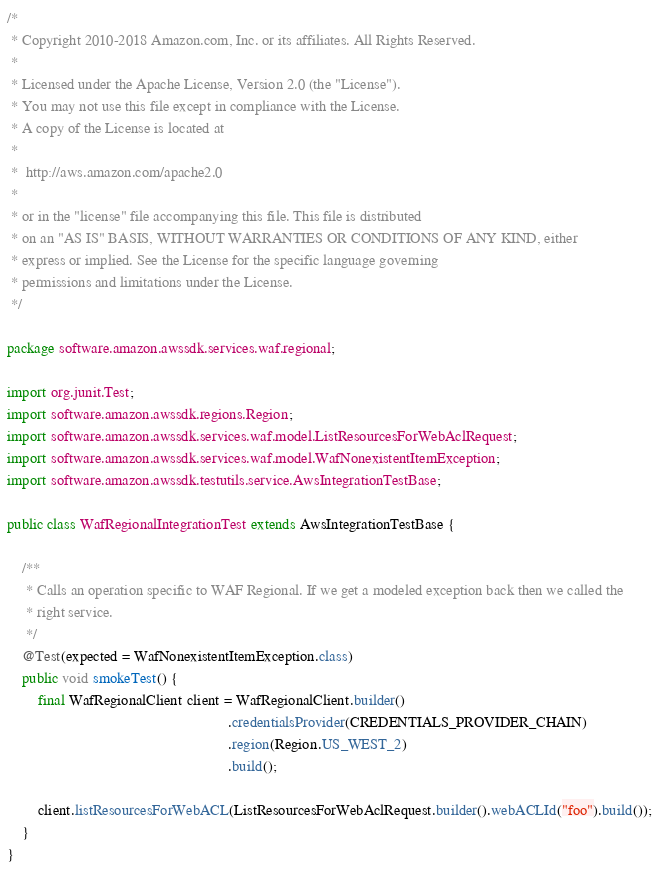<code> <loc_0><loc_0><loc_500><loc_500><_Java_>/*
 * Copyright 2010-2018 Amazon.com, Inc. or its affiliates. All Rights Reserved.
 *
 * Licensed under the Apache License, Version 2.0 (the "License").
 * You may not use this file except in compliance with the License.
 * A copy of the License is located at
 *
 *  http://aws.amazon.com/apache2.0
 *
 * or in the "license" file accompanying this file. This file is distributed
 * on an "AS IS" BASIS, WITHOUT WARRANTIES OR CONDITIONS OF ANY KIND, either
 * express or implied. See the License for the specific language governing
 * permissions and limitations under the License.
 */

package software.amazon.awssdk.services.waf.regional;

import org.junit.Test;
import software.amazon.awssdk.regions.Region;
import software.amazon.awssdk.services.waf.model.ListResourcesForWebAclRequest;
import software.amazon.awssdk.services.waf.model.WafNonexistentItemException;
import software.amazon.awssdk.testutils.service.AwsIntegrationTestBase;

public class WafRegionalIntegrationTest extends AwsIntegrationTestBase {

    /**
     * Calls an operation specific to WAF Regional. If we get a modeled exception back then we called the
     * right service.
     */
    @Test(expected = WafNonexistentItemException.class)
    public void smokeTest() {
        final WafRegionalClient client = WafRegionalClient.builder()
                                                          .credentialsProvider(CREDENTIALS_PROVIDER_CHAIN)
                                                          .region(Region.US_WEST_2)
                                                          .build();

        client.listResourcesForWebACL(ListResourcesForWebAclRequest.builder().webACLId("foo").build());
    }
}
</code> 